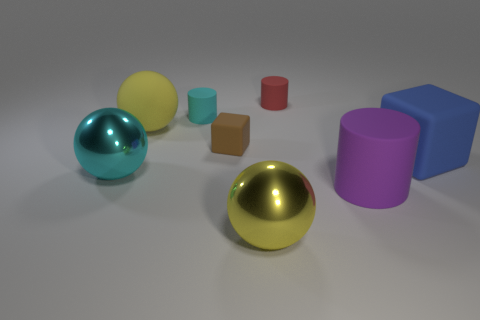Subtract all tiny cylinders. How many cylinders are left? 1 Add 1 large purple cylinders. How many objects exist? 9 Subtract all balls. How many objects are left? 5 Subtract all cyan spheres. Subtract all yellow shiny cylinders. How many objects are left? 7 Add 8 brown matte blocks. How many brown matte blocks are left? 9 Add 4 large matte things. How many large matte things exist? 7 Subtract 0 brown spheres. How many objects are left? 8 